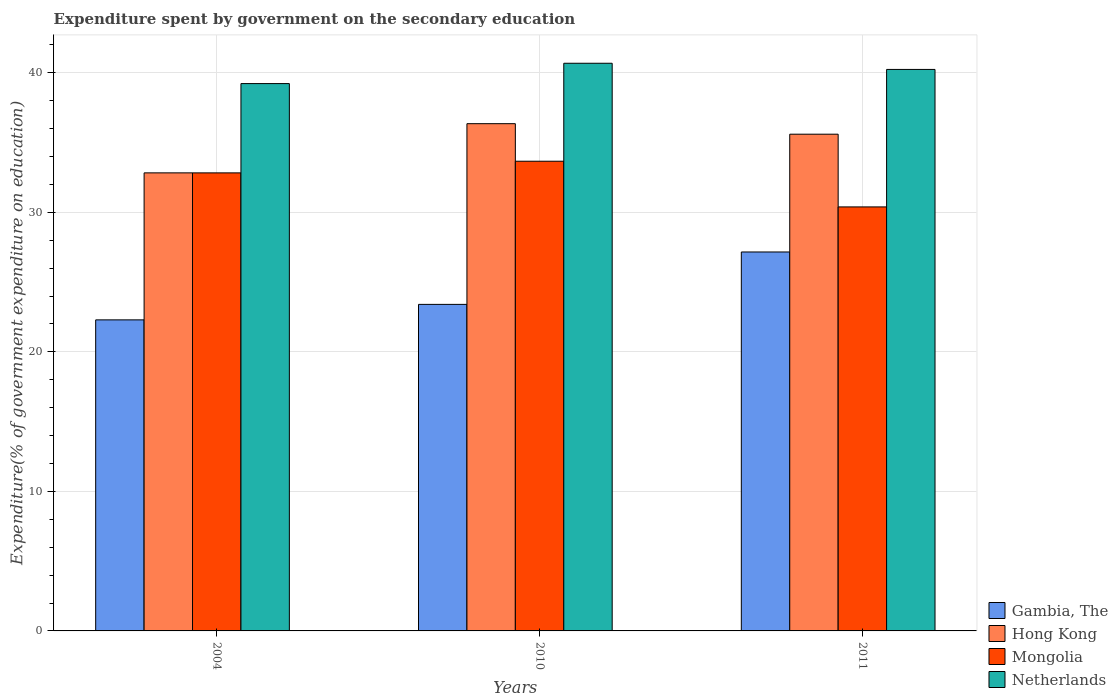How many groups of bars are there?
Keep it short and to the point. 3. Are the number of bars on each tick of the X-axis equal?
Your answer should be compact. Yes. How many bars are there on the 2nd tick from the left?
Your answer should be very brief. 4. What is the label of the 1st group of bars from the left?
Give a very brief answer. 2004. In how many cases, is the number of bars for a given year not equal to the number of legend labels?
Keep it short and to the point. 0. What is the expenditure spent by government on the secondary education in Netherlands in 2004?
Ensure brevity in your answer.  39.22. Across all years, what is the maximum expenditure spent by government on the secondary education in Gambia, The?
Your response must be concise. 27.16. Across all years, what is the minimum expenditure spent by government on the secondary education in Netherlands?
Offer a terse response. 39.22. In which year was the expenditure spent by government on the secondary education in Mongolia minimum?
Offer a terse response. 2011. What is the total expenditure spent by government on the secondary education in Gambia, The in the graph?
Provide a short and direct response. 72.85. What is the difference between the expenditure spent by government on the secondary education in Gambia, The in 2010 and that in 2011?
Ensure brevity in your answer.  -3.76. What is the difference between the expenditure spent by government on the secondary education in Netherlands in 2011 and the expenditure spent by government on the secondary education in Mongolia in 2010?
Make the answer very short. 6.58. What is the average expenditure spent by government on the secondary education in Netherlands per year?
Keep it short and to the point. 40.05. In the year 2010, what is the difference between the expenditure spent by government on the secondary education in Netherlands and expenditure spent by government on the secondary education in Hong Kong?
Give a very brief answer. 4.33. In how many years, is the expenditure spent by government on the secondary education in Hong Kong greater than 40 %?
Ensure brevity in your answer.  0. What is the ratio of the expenditure spent by government on the secondary education in Hong Kong in 2010 to that in 2011?
Give a very brief answer. 1.02. Is the expenditure spent by government on the secondary education in Hong Kong in 2004 less than that in 2011?
Provide a succinct answer. Yes. What is the difference between the highest and the second highest expenditure spent by government on the secondary education in Gambia, The?
Ensure brevity in your answer.  3.76. What is the difference between the highest and the lowest expenditure spent by government on the secondary education in Mongolia?
Provide a short and direct response. 3.27. In how many years, is the expenditure spent by government on the secondary education in Netherlands greater than the average expenditure spent by government on the secondary education in Netherlands taken over all years?
Ensure brevity in your answer.  2. Is the sum of the expenditure spent by government on the secondary education in Gambia, The in 2004 and 2011 greater than the maximum expenditure spent by government on the secondary education in Netherlands across all years?
Give a very brief answer. Yes. Is it the case that in every year, the sum of the expenditure spent by government on the secondary education in Mongolia and expenditure spent by government on the secondary education in Hong Kong is greater than the sum of expenditure spent by government on the secondary education in Gambia, The and expenditure spent by government on the secondary education in Netherlands?
Provide a succinct answer. No. What does the 3rd bar from the left in 2010 represents?
Make the answer very short. Mongolia. What does the 2nd bar from the right in 2011 represents?
Provide a succinct answer. Mongolia. Is it the case that in every year, the sum of the expenditure spent by government on the secondary education in Netherlands and expenditure spent by government on the secondary education in Gambia, The is greater than the expenditure spent by government on the secondary education in Hong Kong?
Make the answer very short. Yes. How many years are there in the graph?
Your response must be concise. 3. Does the graph contain grids?
Provide a succinct answer. Yes. How many legend labels are there?
Offer a very short reply. 4. What is the title of the graph?
Your response must be concise. Expenditure spent by government on the secondary education. Does "Upper middle income" appear as one of the legend labels in the graph?
Offer a terse response. No. What is the label or title of the X-axis?
Your answer should be compact. Years. What is the label or title of the Y-axis?
Your response must be concise. Expenditure(% of government expenditure on education). What is the Expenditure(% of government expenditure on education) of Gambia, The in 2004?
Keep it short and to the point. 22.29. What is the Expenditure(% of government expenditure on education) of Hong Kong in 2004?
Ensure brevity in your answer.  32.83. What is the Expenditure(% of government expenditure on education) of Mongolia in 2004?
Your answer should be compact. 32.83. What is the Expenditure(% of government expenditure on education) in Netherlands in 2004?
Make the answer very short. 39.22. What is the Expenditure(% of government expenditure on education) in Gambia, The in 2010?
Provide a short and direct response. 23.4. What is the Expenditure(% of government expenditure on education) of Hong Kong in 2010?
Give a very brief answer. 36.35. What is the Expenditure(% of government expenditure on education) of Mongolia in 2010?
Your response must be concise. 33.66. What is the Expenditure(% of government expenditure on education) in Netherlands in 2010?
Your answer should be compact. 40.68. What is the Expenditure(% of government expenditure on education) in Gambia, The in 2011?
Provide a short and direct response. 27.16. What is the Expenditure(% of government expenditure on education) in Hong Kong in 2011?
Keep it short and to the point. 35.6. What is the Expenditure(% of government expenditure on education) of Mongolia in 2011?
Offer a very short reply. 30.39. What is the Expenditure(% of government expenditure on education) of Netherlands in 2011?
Provide a short and direct response. 40.24. Across all years, what is the maximum Expenditure(% of government expenditure on education) of Gambia, The?
Make the answer very short. 27.16. Across all years, what is the maximum Expenditure(% of government expenditure on education) in Hong Kong?
Provide a succinct answer. 36.35. Across all years, what is the maximum Expenditure(% of government expenditure on education) in Mongolia?
Your response must be concise. 33.66. Across all years, what is the maximum Expenditure(% of government expenditure on education) in Netherlands?
Provide a succinct answer. 40.68. Across all years, what is the minimum Expenditure(% of government expenditure on education) in Gambia, The?
Offer a terse response. 22.29. Across all years, what is the minimum Expenditure(% of government expenditure on education) of Hong Kong?
Provide a succinct answer. 32.83. Across all years, what is the minimum Expenditure(% of government expenditure on education) of Mongolia?
Give a very brief answer. 30.39. Across all years, what is the minimum Expenditure(% of government expenditure on education) of Netherlands?
Ensure brevity in your answer.  39.22. What is the total Expenditure(% of government expenditure on education) of Gambia, The in the graph?
Your answer should be very brief. 72.85. What is the total Expenditure(% of government expenditure on education) of Hong Kong in the graph?
Offer a terse response. 104.78. What is the total Expenditure(% of government expenditure on education) of Mongolia in the graph?
Keep it short and to the point. 96.87. What is the total Expenditure(% of government expenditure on education) of Netherlands in the graph?
Your answer should be very brief. 120.14. What is the difference between the Expenditure(% of government expenditure on education) of Gambia, The in 2004 and that in 2010?
Give a very brief answer. -1.11. What is the difference between the Expenditure(% of government expenditure on education) of Hong Kong in 2004 and that in 2010?
Your response must be concise. -3.52. What is the difference between the Expenditure(% of government expenditure on education) of Mongolia in 2004 and that in 2010?
Provide a succinct answer. -0.83. What is the difference between the Expenditure(% of government expenditure on education) in Netherlands in 2004 and that in 2010?
Your answer should be compact. -1.46. What is the difference between the Expenditure(% of government expenditure on education) of Gambia, The in 2004 and that in 2011?
Offer a very short reply. -4.86. What is the difference between the Expenditure(% of government expenditure on education) in Hong Kong in 2004 and that in 2011?
Give a very brief answer. -2.77. What is the difference between the Expenditure(% of government expenditure on education) of Mongolia in 2004 and that in 2011?
Your response must be concise. 2.44. What is the difference between the Expenditure(% of government expenditure on education) in Netherlands in 2004 and that in 2011?
Ensure brevity in your answer.  -1.01. What is the difference between the Expenditure(% of government expenditure on education) in Gambia, The in 2010 and that in 2011?
Provide a short and direct response. -3.76. What is the difference between the Expenditure(% of government expenditure on education) of Hong Kong in 2010 and that in 2011?
Provide a succinct answer. 0.75. What is the difference between the Expenditure(% of government expenditure on education) of Mongolia in 2010 and that in 2011?
Provide a short and direct response. 3.27. What is the difference between the Expenditure(% of government expenditure on education) in Netherlands in 2010 and that in 2011?
Offer a very short reply. 0.44. What is the difference between the Expenditure(% of government expenditure on education) in Gambia, The in 2004 and the Expenditure(% of government expenditure on education) in Hong Kong in 2010?
Your response must be concise. -14.06. What is the difference between the Expenditure(% of government expenditure on education) in Gambia, The in 2004 and the Expenditure(% of government expenditure on education) in Mongolia in 2010?
Make the answer very short. -11.37. What is the difference between the Expenditure(% of government expenditure on education) in Gambia, The in 2004 and the Expenditure(% of government expenditure on education) in Netherlands in 2010?
Keep it short and to the point. -18.39. What is the difference between the Expenditure(% of government expenditure on education) in Hong Kong in 2004 and the Expenditure(% of government expenditure on education) in Mongolia in 2010?
Give a very brief answer. -0.83. What is the difference between the Expenditure(% of government expenditure on education) of Hong Kong in 2004 and the Expenditure(% of government expenditure on education) of Netherlands in 2010?
Ensure brevity in your answer.  -7.86. What is the difference between the Expenditure(% of government expenditure on education) in Mongolia in 2004 and the Expenditure(% of government expenditure on education) in Netherlands in 2010?
Offer a terse response. -7.86. What is the difference between the Expenditure(% of government expenditure on education) in Gambia, The in 2004 and the Expenditure(% of government expenditure on education) in Hong Kong in 2011?
Keep it short and to the point. -13.31. What is the difference between the Expenditure(% of government expenditure on education) in Gambia, The in 2004 and the Expenditure(% of government expenditure on education) in Mongolia in 2011?
Your answer should be compact. -8.09. What is the difference between the Expenditure(% of government expenditure on education) of Gambia, The in 2004 and the Expenditure(% of government expenditure on education) of Netherlands in 2011?
Give a very brief answer. -17.95. What is the difference between the Expenditure(% of government expenditure on education) of Hong Kong in 2004 and the Expenditure(% of government expenditure on education) of Mongolia in 2011?
Offer a very short reply. 2.44. What is the difference between the Expenditure(% of government expenditure on education) of Hong Kong in 2004 and the Expenditure(% of government expenditure on education) of Netherlands in 2011?
Provide a short and direct response. -7.41. What is the difference between the Expenditure(% of government expenditure on education) of Mongolia in 2004 and the Expenditure(% of government expenditure on education) of Netherlands in 2011?
Ensure brevity in your answer.  -7.41. What is the difference between the Expenditure(% of government expenditure on education) in Gambia, The in 2010 and the Expenditure(% of government expenditure on education) in Hong Kong in 2011?
Make the answer very short. -12.2. What is the difference between the Expenditure(% of government expenditure on education) of Gambia, The in 2010 and the Expenditure(% of government expenditure on education) of Mongolia in 2011?
Offer a terse response. -6.99. What is the difference between the Expenditure(% of government expenditure on education) in Gambia, The in 2010 and the Expenditure(% of government expenditure on education) in Netherlands in 2011?
Your response must be concise. -16.84. What is the difference between the Expenditure(% of government expenditure on education) of Hong Kong in 2010 and the Expenditure(% of government expenditure on education) of Mongolia in 2011?
Keep it short and to the point. 5.96. What is the difference between the Expenditure(% of government expenditure on education) of Hong Kong in 2010 and the Expenditure(% of government expenditure on education) of Netherlands in 2011?
Your response must be concise. -3.89. What is the difference between the Expenditure(% of government expenditure on education) in Mongolia in 2010 and the Expenditure(% of government expenditure on education) in Netherlands in 2011?
Provide a short and direct response. -6.58. What is the average Expenditure(% of government expenditure on education) of Gambia, The per year?
Offer a very short reply. 24.28. What is the average Expenditure(% of government expenditure on education) of Hong Kong per year?
Keep it short and to the point. 34.93. What is the average Expenditure(% of government expenditure on education) of Mongolia per year?
Offer a very short reply. 32.29. What is the average Expenditure(% of government expenditure on education) in Netherlands per year?
Offer a terse response. 40.05. In the year 2004, what is the difference between the Expenditure(% of government expenditure on education) in Gambia, The and Expenditure(% of government expenditure on education) in Hong Kong?
Your answer should be compact. -10.53. In the year 2004, what is the difference between the Expenditure(% of government expenditure on education) in Gambia, The and Expenditure(% of government expenditure on education) in Mongolia?
Give a very brief answer. -10.53. In the year 2004, what is the difference between the Expenditure(% of government expenditure on education) of Gambia, The and Expenditure(% of government expenditure on education) of Netherlands?
Provide a short and direct response. -16.93. In the year 2004, what is the difference between the Expenditure(% of government expenditure on education) in Hong Kong and Expenditure(% of government expenditure on education) in Mongolia?
Your response must be concise. 0. In the year 2004, what is the difference between the Expenditure(% of government expenditure on education) in Hong Kong and Expenditure(% of government expenditure on education) in Netherlands?
Offer a very short reply. -6.4. In the year 2004, what is the difference between the Expenditure(% of government expenditure on education) in Mongolia and Expenditure(% of government expenditure on education) in Netherlands?
Make the answer very short. -6.4. In the year 2010, what is the difference between the Expenditure(% of government expenditure on education) in Gambia, The and Expenditure(% of government expenditure on education) in Hong Kong?
Your response must be concise. -12.95. In the year 2010, what is the difference between the Expenditure(% of government expenditure on education) of Gambia, The and Expenditure(% of government expenditure on education) of Mongolia?
Your answer should be very brief. -10.26. In the year 2010, what is the difference between the Expenditure(% of government expenditure on education) in Gambia, The and Expenditure(% of government expenditure on education) in Netherlands?
Your answer should be compact. -17.28. In the year 2010, what is the difference between the Expenditure(% of government expenditure on education) of Hong Kong and Expenditure(% of government expenditure on education) of Mongolia?
Offer a very short reply. 2.69. In the year 2010, what is the difference between the Expenditure(% of government expenditure on education) of Hong Kong and Expenditure(% of government expenditure on education) of Netherlands?
Offer a terse response. -4.33. In the year 2010, what is the difference between the Expenditure(% of government expenditure on education) in Mongolia and Expenditure(% of government expenditure on education) in Netherlands?
Your answer should be compact. -7.02. In the year 2011, what is the difference between the Expenditure(% of government expenditure on education) in Gambia, The and Expenditure(% of government expenditure on education) in Hong Kong?
Give a very brief answer. -8.44. In the year 2011, what is the difference between the Expenditure(% of government expenditure on education) of Gambia, The and Expenditure(% of government expenditure on education) of Mongolia?
Keep it short and to the point. -3.23. In the year 2011, what is the difference between the Expenditure(% of government expenditure on education) of Gambia, The and Expenditure(% of government expenditure on education) of Netherlands?
Provide a short and direct response. -13.08. In the year 2011, what is the difference between the Expenditure(% of government expenditure on education) in Hong Kong and Expenditure(% of government expenditure on education) in Mongolia?
Make the answer very short. 5.21. In the year 2011, what is the difference between the Expenditure(% of government expenditure on education) in Hong Kong and Expenditure(% of government expenditure on education) in Netherlands?
Your response must be concise. -4.64. In the year 2011, what is the difference between the Expenditure(% of government expenditure on education) in Mongolia and Expenditure(% of government expenditure on education) in Netherlands?
Provide a succinct answer. -9.85. What is the ratio of the Expenditure(% of government expenditure on education) of Gambia, The in 2004 to that in 2010?
Give a very brief answer. 0.95. What is the ratio of the Expenditure(% of government expenditure on education) in Hong Kong in 2004 to that in 2010?
Give a very brief answer. 0.9. What is the ratio of the Expenditure(% of government expenditure on education) of Mongolia in 2004 to that in 2010?
Give a very brief answer. 0.98. What is the ratio of the Expenditure(% of government expenditure on education) of Netherlands in 2004 to that in 2010?
Your answer should be very brief. 0.96. What is the ratio of the Expenditure(% of government expenditure on education) of Gambia, The in 2004 to that in 2011?
Ensure brevity in your answer.  0.82. What is the ratio of the Expenditure(% of government expenditure on education) of Hong Kong in 2004 to that in 2011?
Ensure brevity in your answer.  0.92. What is the ratio of the Expenditure(% of government expenditure on education) in Mongolia in 2004 to that in 2011?
Give a very brief answer. 1.08. What is the ratio of the Expenditure(% of government expenditure on education) of Netherlands in 2004 to that in 2011?
Provide a short and direct response. 0.97. What is the ratio of the Expenditure(% of government expenditure on education) in Gambia, The in 2010 to that in 2011?
Offer a very short reply. 0.86. What is the ratio of the Expenditure(% of government expenditure on education) of Hong Kong in 2010 to that in 2011?
Your response must be concise. 1.02. What is the ratio of the Expenditure(% of government expenditure on education) in Mongolia in 2010 to that in 2011?
Provide a short and direct response. 1.11. What is the ratio of the Expenditure(% of government expenditure on education) of Netherlands in 2010 to that in 2011?
Offer a terse response. 1.01. What is the difference between the highest and the second highest Expenditure(% of government expenditure on education) of Gambia, The?
Make the answer very short. 3.76. What is the difference between the highest and the second highest Expenditure(% of government expenditure on education) in Hong Kong?
Make the answer very short. 0.75. What is the difference between the highest and the second highest Expenditure(% of government expenditure on education) of Mongolia?
Provide a short and direct response. 0.83. What is the difference between the highest and the second highest Expenditure(% of government expenditure on education) in Netherlands?
Provide a succinct answer. 0.44. What is the difference between the highest and the lowest Expenditure(% of government expenditure on education) of Gambia, The?
Offer a terse response. 4.86. What is the difference between the highest and the lowest Expenditure(% of government expenditure on education) in Hong Kong?
Your response must be concise. 3.52. What is the difference between the highest and the lowest Expenditure(% of government expenditure on education) in Mongolia?
Provide a short and direct response. 3.27. What is the difference between the highest and the lowest Expenditure(% of government expenditure on education) in Netherlands?
Keep it short and to the point. 1.46. 